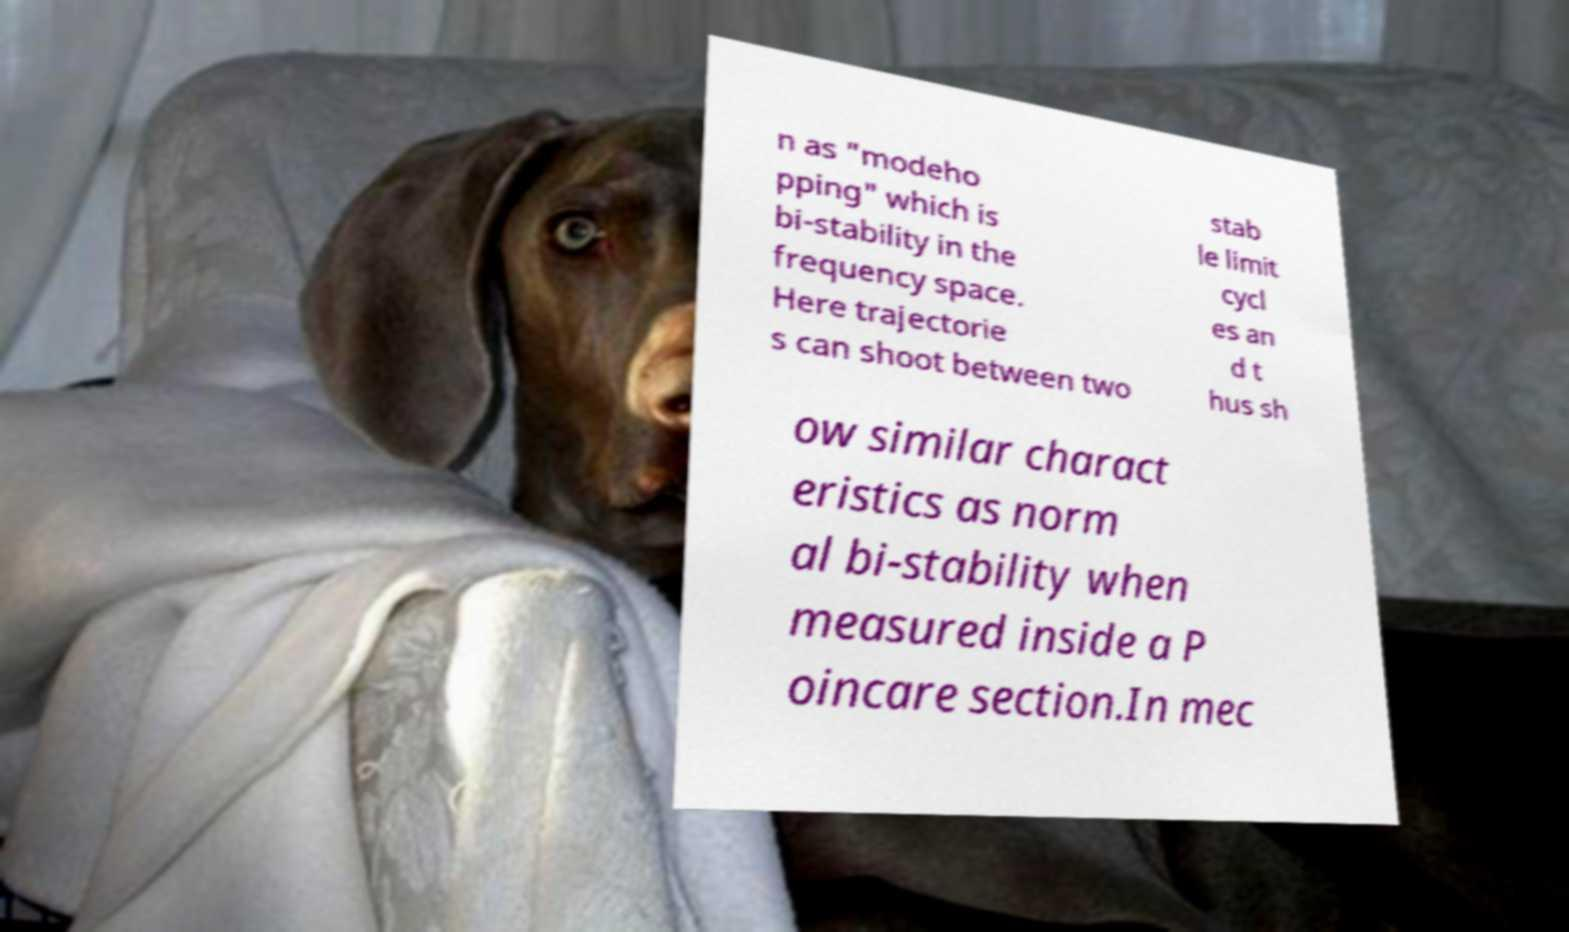Please identify and transcribe the text found in this image. n as "modeho pping" which is bi-stability in the frequency space. Here trajectorie s can shoot between two stab le limit cycl es an d t hus sh ow similar charact eristics as norm al bi-stability when measured inside a P oincare section.In mec 